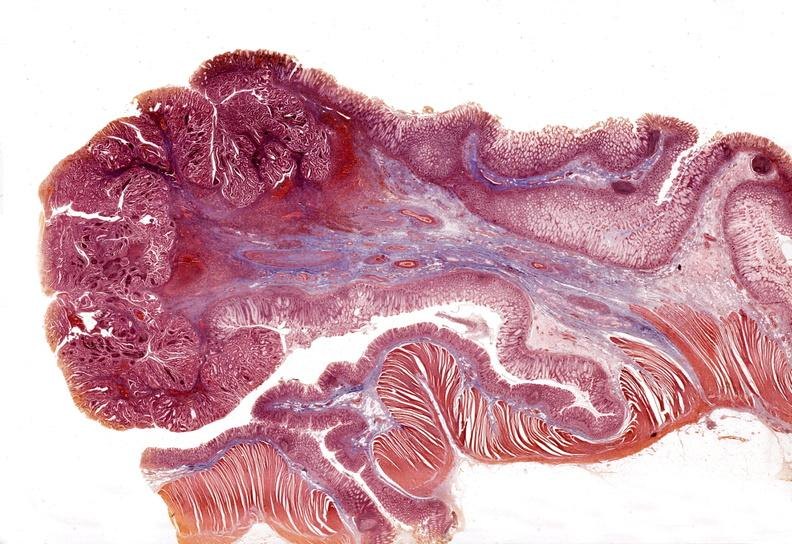does this image show stomach, adenomatous polyp and malignant focus?
Answer the question using a single word or phrase. Yes 